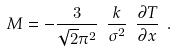Convert formula to latex. <formula><loc_0><loc_0><loc_500><loc_500>M = - \frac { 3 } { \sqrt { 2 } \pi ^ { 2 } } \ \frac { k } { \sigma ^ { 2 } } \ \frac { \partial T } { \partial x } \ .</formula> 